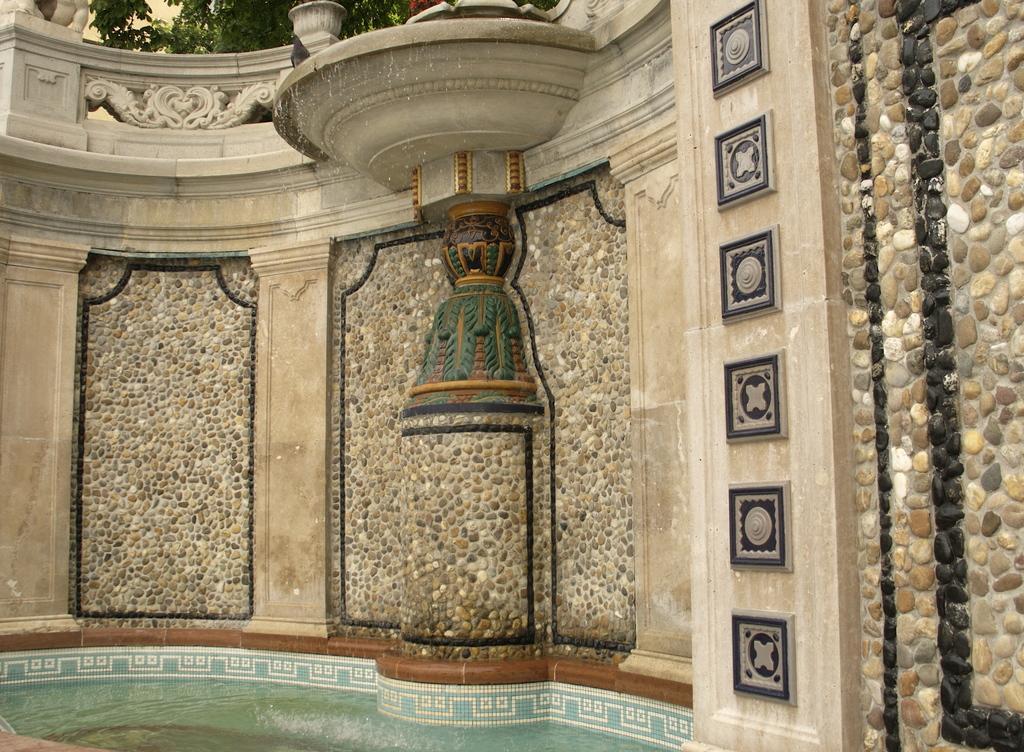Please provide a concise description of this image. Here we can see designed wall, plants and water. 